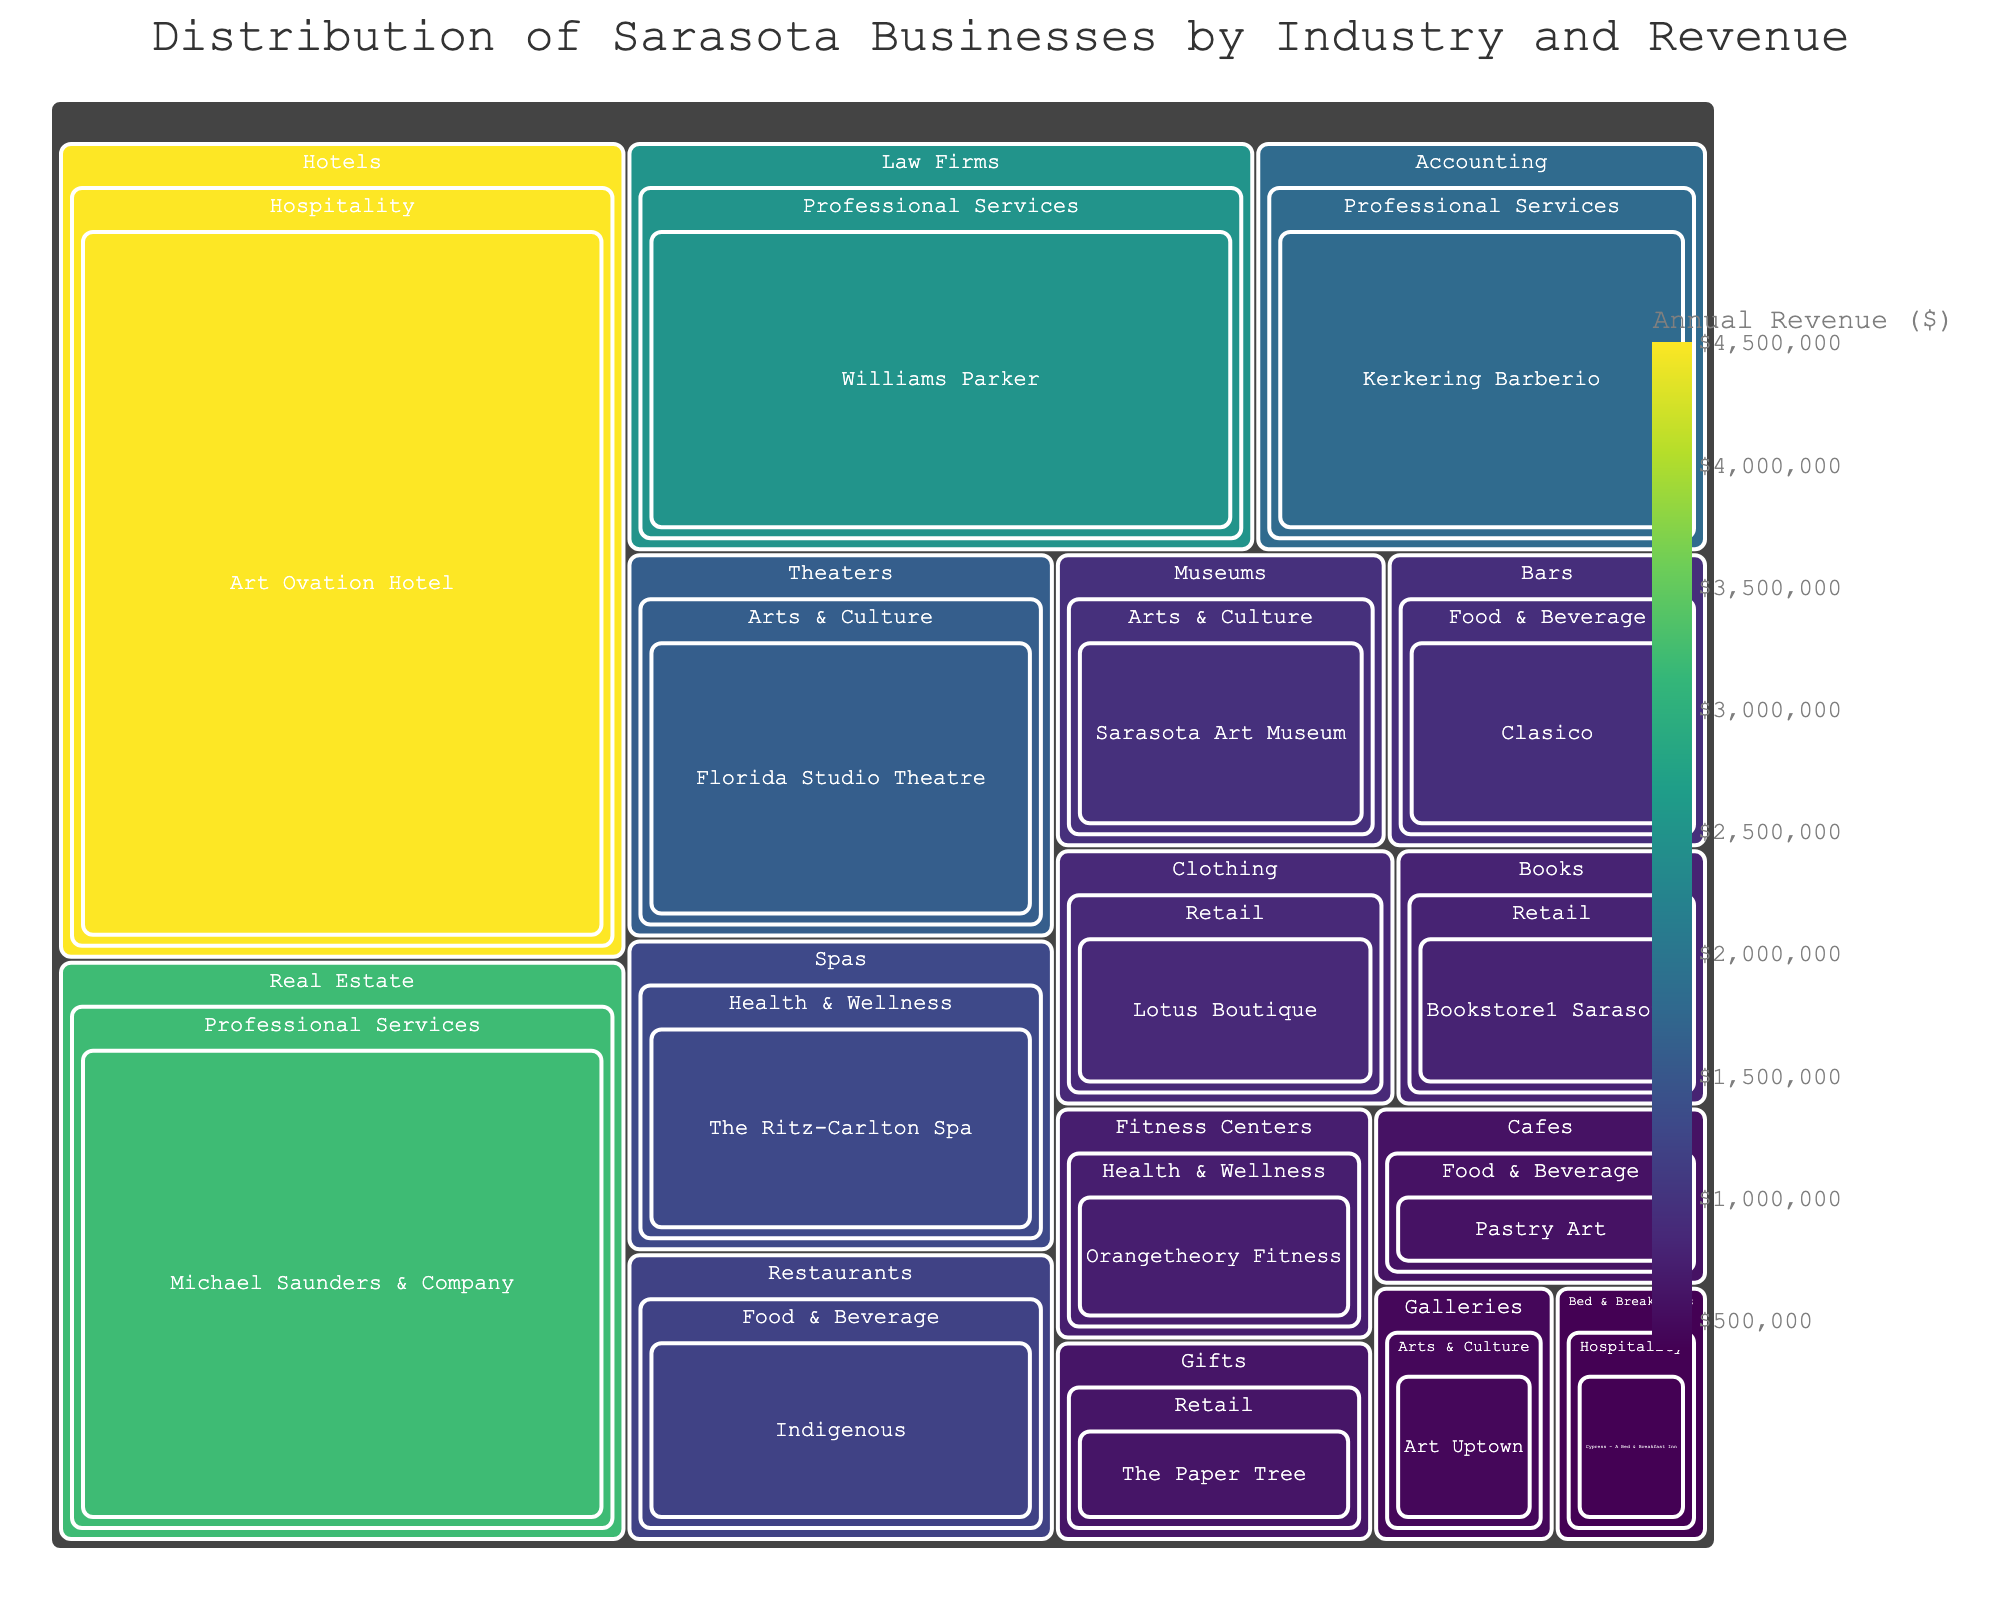What is the title of the treemap? The title of the treemap is usually displayed at the top of the figure. In this case, the title is given as 'Distribution of Sarasota Businesses by Industry and Revenue.'
Answer: Distribution of Sarasota Businesses by Industry and Revenue Which business sector has the highest annual revenue? To answer this question, look for the sector with the largest and darkest colored area in the treemap. This indicates the highest revenue. The 'Hospitality' sector has the highest annual revenue as indicated by 'Art Ovation Hotel' with $4,500,000.
Answer: Hospitality What is the annual revenue of the 'Florida Studio Theatre'? Locate the 'Arts & Culture' sector and then the 'Theaters' industry in the treemap. Find the box labeled 'Florida Studio Theatre' and check its revenue, which is $1,600,000.
Answer: $1,600,000 Which sector contains the business with the lowest revenue, and what is that revenue? To find the business with the lowest revenue, look for the smallest and lightest colored box. 'Cypress - A Bed & Breakfast Inn' in the 'Hospitality' sector has the lowest revenue of $380,000.
Answer: Hospitality, $380,000 Compare the revenue of 'Williams Parker' and 'Michael Saunders & Company'. Which one is higher and by how much? Locate both businesses in the 'Professional Services' sector. 'Williams Parker' has a revenue of $2,500,000 and 'Michael Saunders & Company' has a revenue of $3,200,000. The difference is $3,200,000 - $2,500,000 = $700,000.
Answer: Michael Saunders & Company, $700,000 What is the total revenue for the 'Food & Beverage' sector? Sum up the revenues of all businesses in the 'Food & Beverage' sector: Indigenous ($1,200,000), Pastry Art ($580,000), Clasico ($920,000). Total is $1,200,000 + $580,000 + $920,000 = $2,700,000.
Answer: $2,700,000 How does the revenue of 'Orangetheory Fitness' compare to the combined revenue of all businesses in the 'Retail' sector? First, find 'Orangetheory Fitness' revenue which is $720,000. Then calculate the total revenue for the 'Retail' sector: Lotus Boutique ($850,000), The Paper Tree ($620,000), Bookstore1 Sarasota ($780,000). Total is $850,000 + $620,000 + $780,000 = $2,250,000. Compare $720,000 to $2,250,000.
Answer: Less, $1,530,000 less What is the average revenue of businesses in the 'Arts & Culture' sector? Find the total revenue of businesses in the 'Arts & Culture' sector and divide by the number of businesses. Art Uptown ($450,000), Florida Studio Theatre ($1,600,000), Sarasota Art Museum ($950,000). Total is $450,000 + $1,600,000 + $950,000 = $3,000,000. Average is $3,000,000 / 3 = $1,000,000.
Answer: $1,000,000 In which sector and industry is 'Bookstore1 Sarasota' located? Locate 'Bookstore1 Sarasota' on the treemap. It is found in the 'Retail' sector and 'Books' industry.
Answer: Retail, Books 